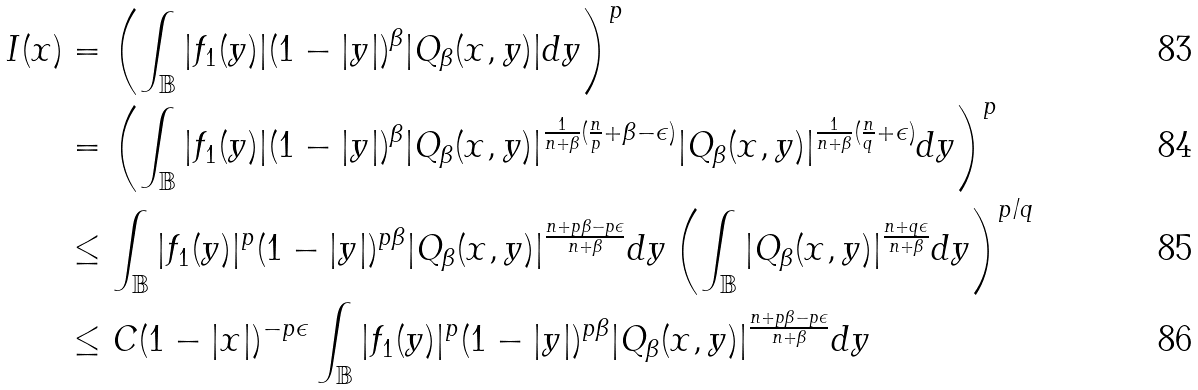Convert formula to latex. <formula><loc_0><loc_0><loc_500><loc_500>I ( x ) & = \left ( \int _ { \mathbb { B } } | f _ { 1 } ( y ) | ( 1 - | y | ) ^ { \beta } | Q _ { \beta } ( x , y ) | d y \right ) ^ { p } \\ & = \left ( \int _ { \mathbb { B } } | f _ { 1 } ( y ) | ( 1 - | y | ) ^ { \beta } | Q _ { \beta } ( x , y ) | ^ { \frac { 1 } { n + \beta } ( \frac { n } { p } + \beta - \epsilon ) } | Q _ { \beta } ( x , y ) | ^ { \frac { 1 } { n + \beta } ( \frac { n } { q } + \epsilon ) } d y \right ) ^ { p } \\ & \leq \int _ { \mathbb { B } } | f _ { 1 } ( y ) | ^ { p } ( 1 - | y | ) ^ { p \beta } | Q _ { \beta } ( x , y ) | ^ { \frac { n + p \beta - p \epsilon } { n + \beta } } d y \left ( \int _ { \mathbb { B } } | Q _ { \beta } ( x , y ) | ^ { \frac { n + q \epsilon } { n + \beta } } d y \right ) ^ { p / q } \\ & \leq C ( 1 - | x | ) ^ { - p \epsilon } \int _ { \mathbb { B } } | f _ { 1 } ( y ) | ^ { p } ( 1 - | y | ) ^ { p \beta } | Q _ { \beta } ( x , y ) | ^ { \frac { n + p \beta - p \epsilon } { n + \beta } } d y</formula> 